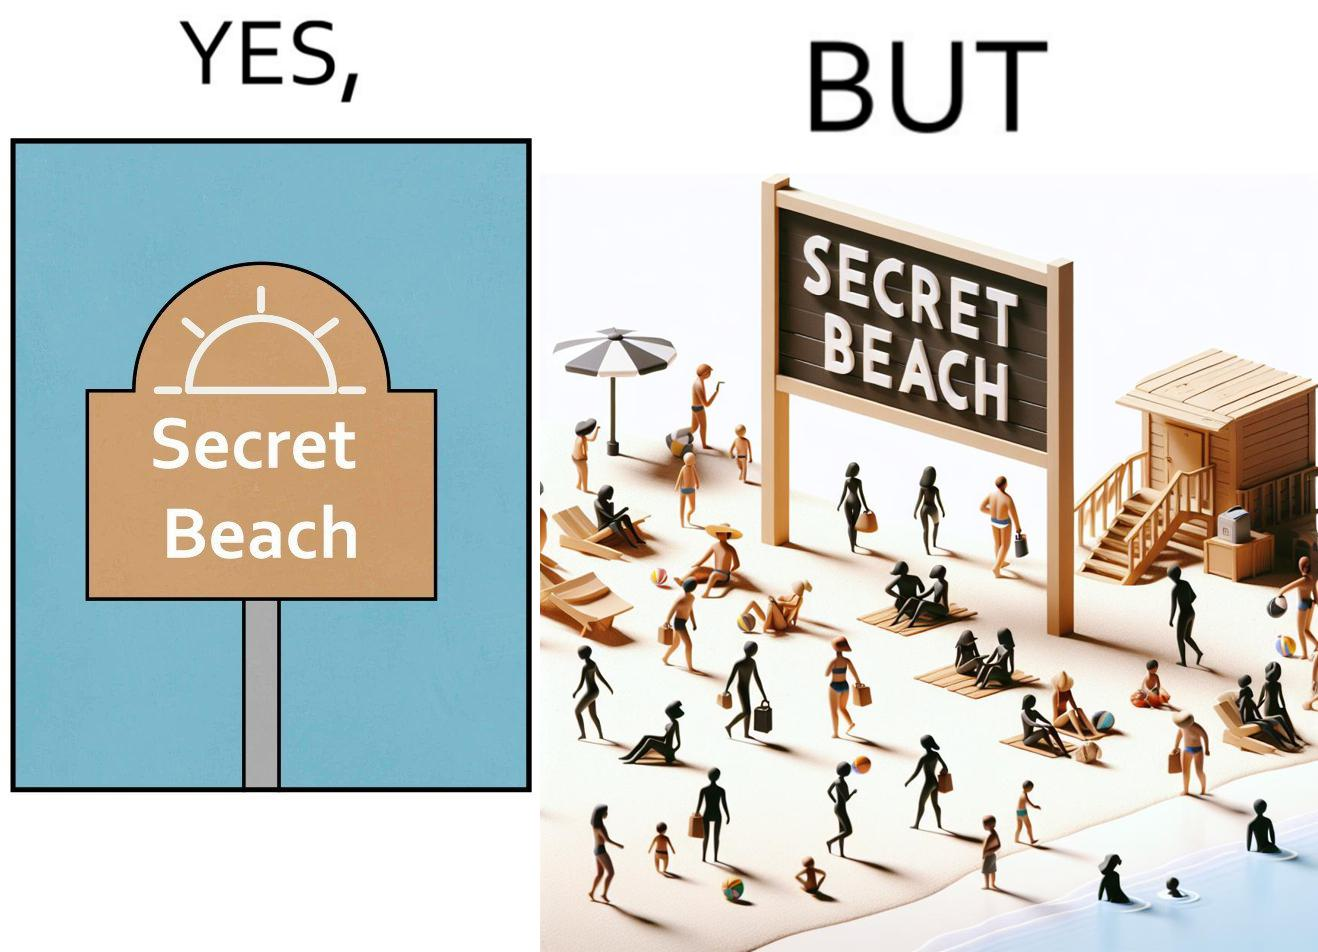Why is this image considered satirical? The image is ironical, as people can be seen in the beach, and is clearly not a secret, while the board at the entrance has "Secret Beach" written on it. 